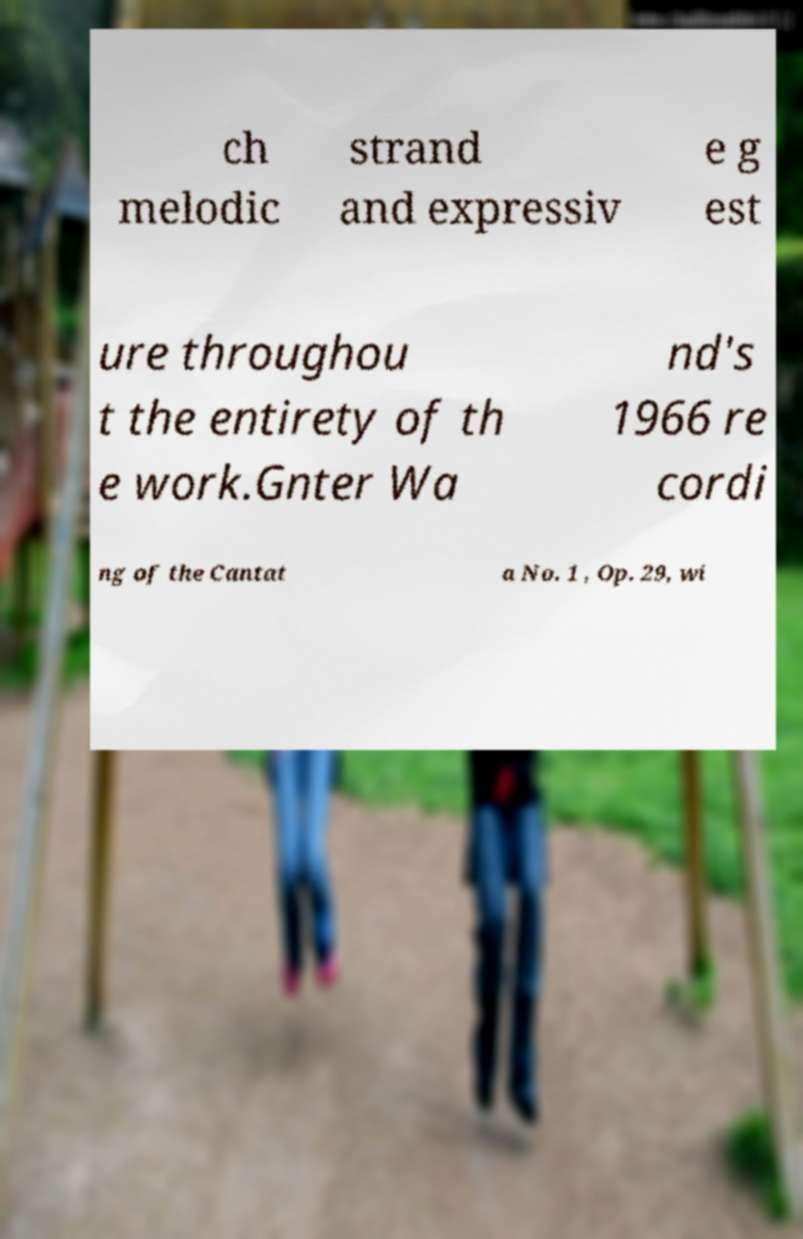What messages or text are displayed in this image? I need them in a readable, typed format. ch melodic strand and expressiv e g est ure throughou t the entirety of th e work.Gnter Wa nd's 1966 re cordi ng of the Cantat a No. 1 , Op. 29, wi 